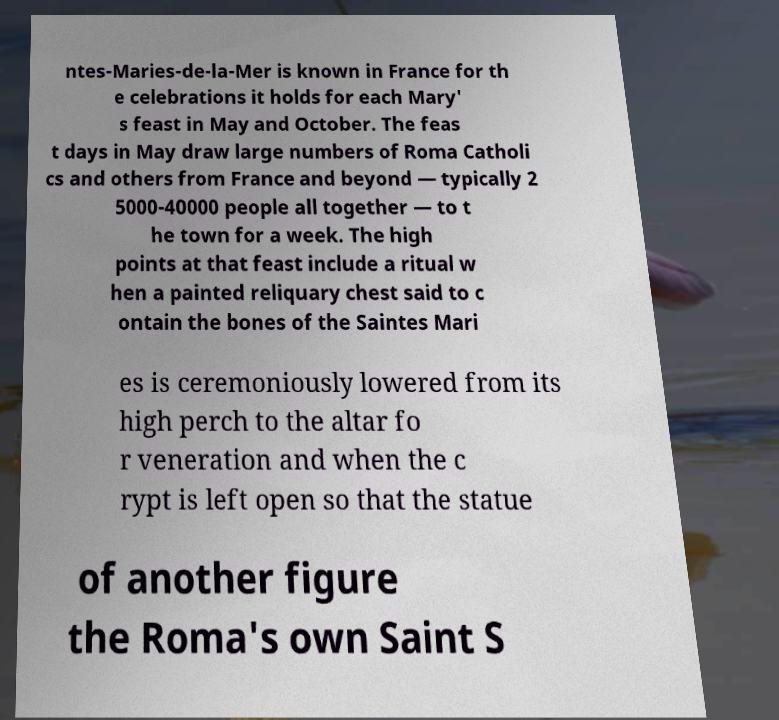Please identify and transcribe the text found in this image. ntes-Maries-de-la-Mer is known in France for th e celebrations it holds for each Mary' s feast in May and October. The feas t days in May draw large numbers of Roma Catholi cs and others from France and beyond — typically 2 5000-40000 people all together — to t he town for a week. The high points at that feast include a ritual w hen a painted reliquary chest said to c ontain the bones of the Saintes Mari es is ceremoniously lowered from its high perch to the altar fo r veneration and when the c rypt is left open so that the statue of another figure the Roma's own Saint S 